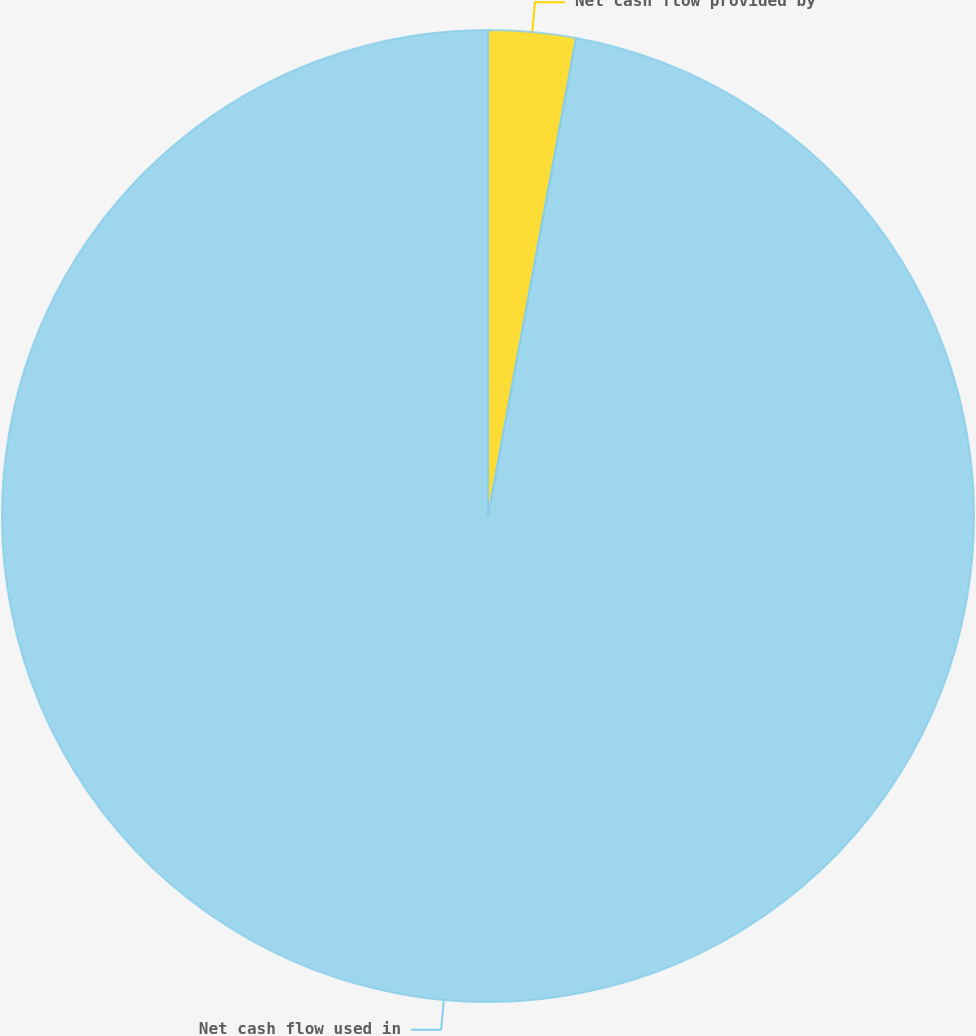Convert chart. <chart><loc_0><loc_0><loc_500><loc_500><pie_chart><fcel>Net cash flow provided by<fcel>Net cash flow used in<nl><fcel>2.9%<fcel>97.1%<nl></chart> 